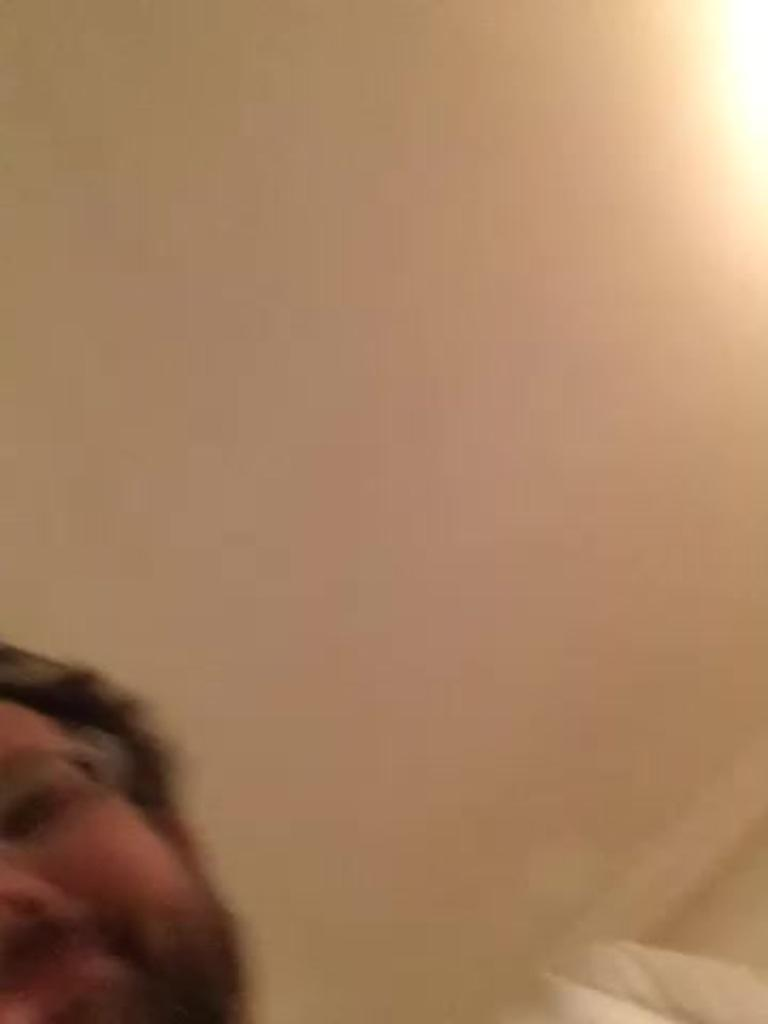What is the quality of the image? The image is blurry. What can be seen in the image despite its blurriness? The half face of a man is visible in the image. What type of anger is the man expressing in the image? There is no indication of anger in the image, as only the half face of a man is visible and it is blurry. Are there any chickens present in the image? No, there are no chickens present in the image. 